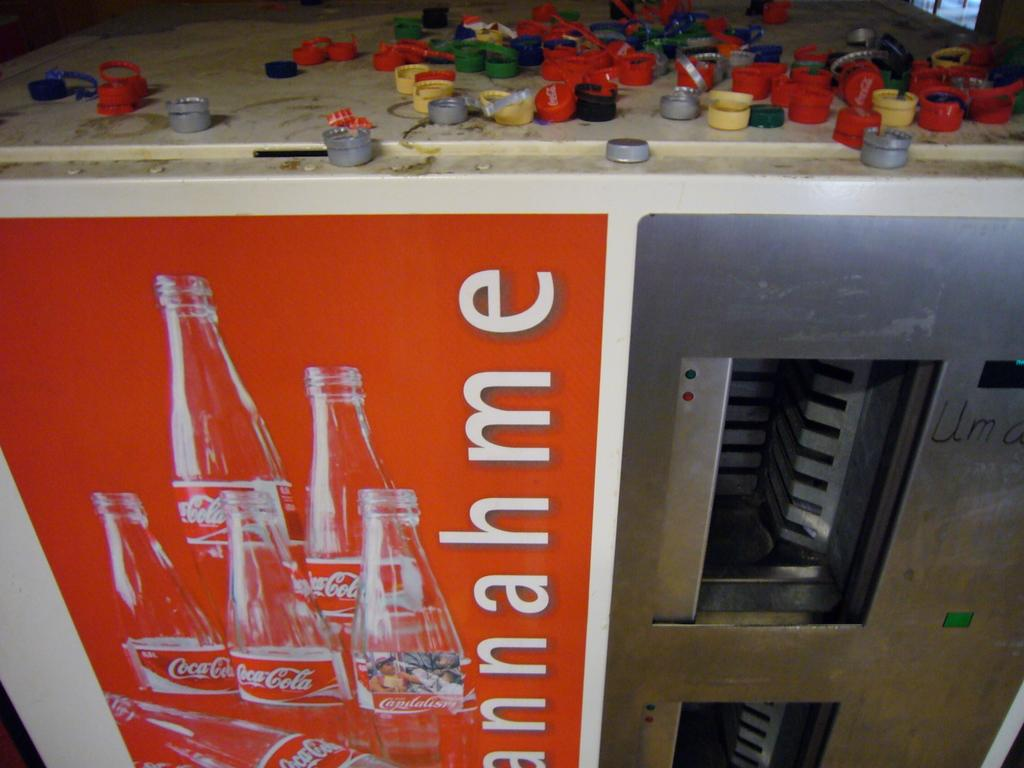What is the main object in the image? There is a machine in the image. What is attached to the machine? There is a poster with images on the machine. What can be read on the poster? There is text written on the poster. What is located above the machine? There are bottle caps above the machine. Can you tell me who won the argument in the image? There is no argument present in the image; it features a machine with a poster and bottle caps. How does the end of the machine look like in the image? The image does not show the end of the machine; it only shows the front or side of the machine. 